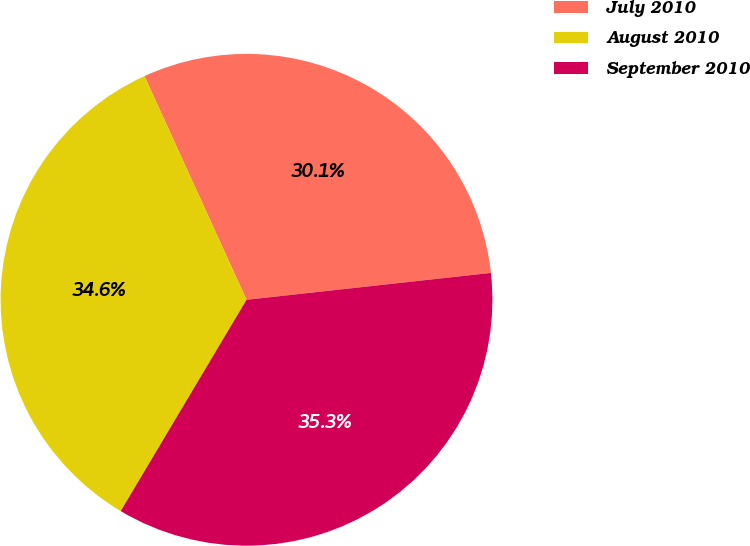<chart> <loc_0><loc_0><loc_500><loc_500><pie_chart><fcel>July 2010<fcel>August 2010<fcel>September 2010<nl><fcel>30.07%<fcel>34.64%<fcel>35.29%<nl></chart> 